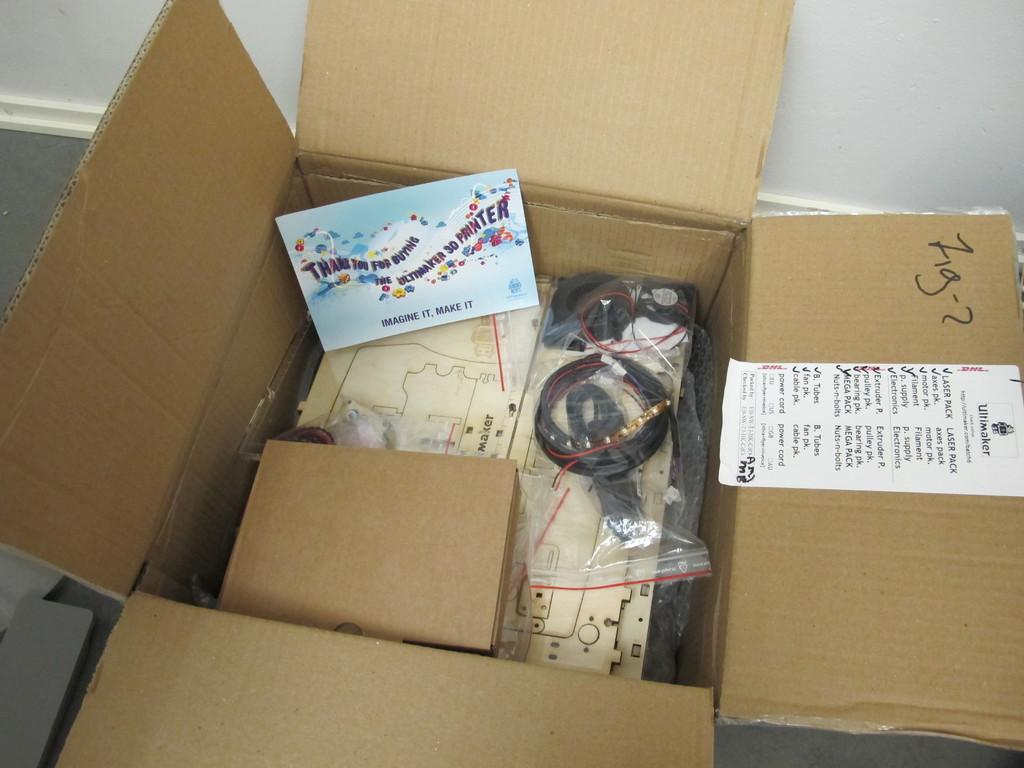<image>
Relay a brief, clear account of the picture shown. an open box has a card reading Thanks for buying the ultimate 3D printer 